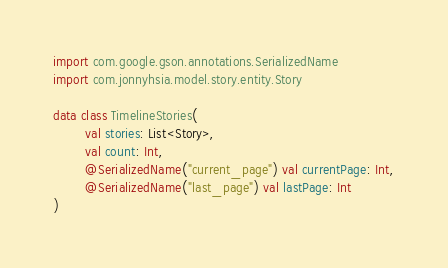Convert code to text. <code><loc_0><loc_0><loc_500><loc_500><_Kotlin_>import com.google.gson.annotations.SerializedName
import com.jonnyhsia.model.story.entity.Story

data class TimelineStories(
        val stories: List<Story>,
        val count: Int,
        @SerializedName("current_page") val currentPage: Int,
        @SerializedName("last_page") val lastPage: Int
)
</code> 